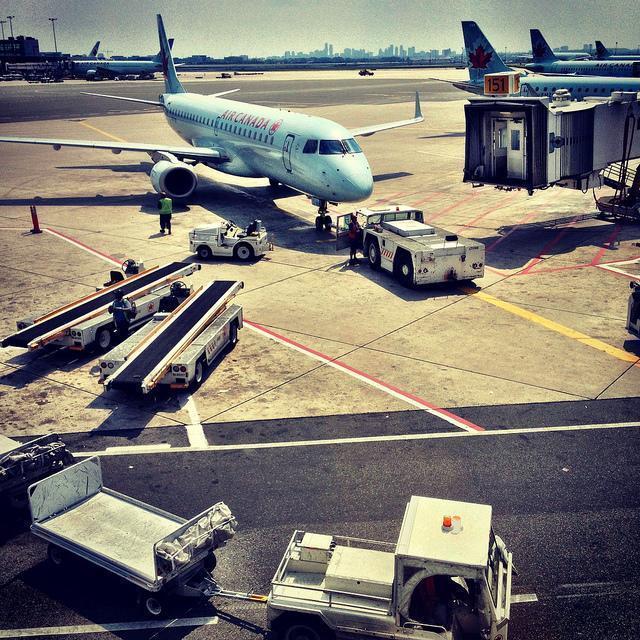What does the vehicle that will be used to move the plane face?
Pick the right solution, then justify: 'Answer: answer
Rationale: rationale.'
Options: Nothing, plane, airport side, tow truck. Answer: plane.
Rationale: This is self-explanatory. 